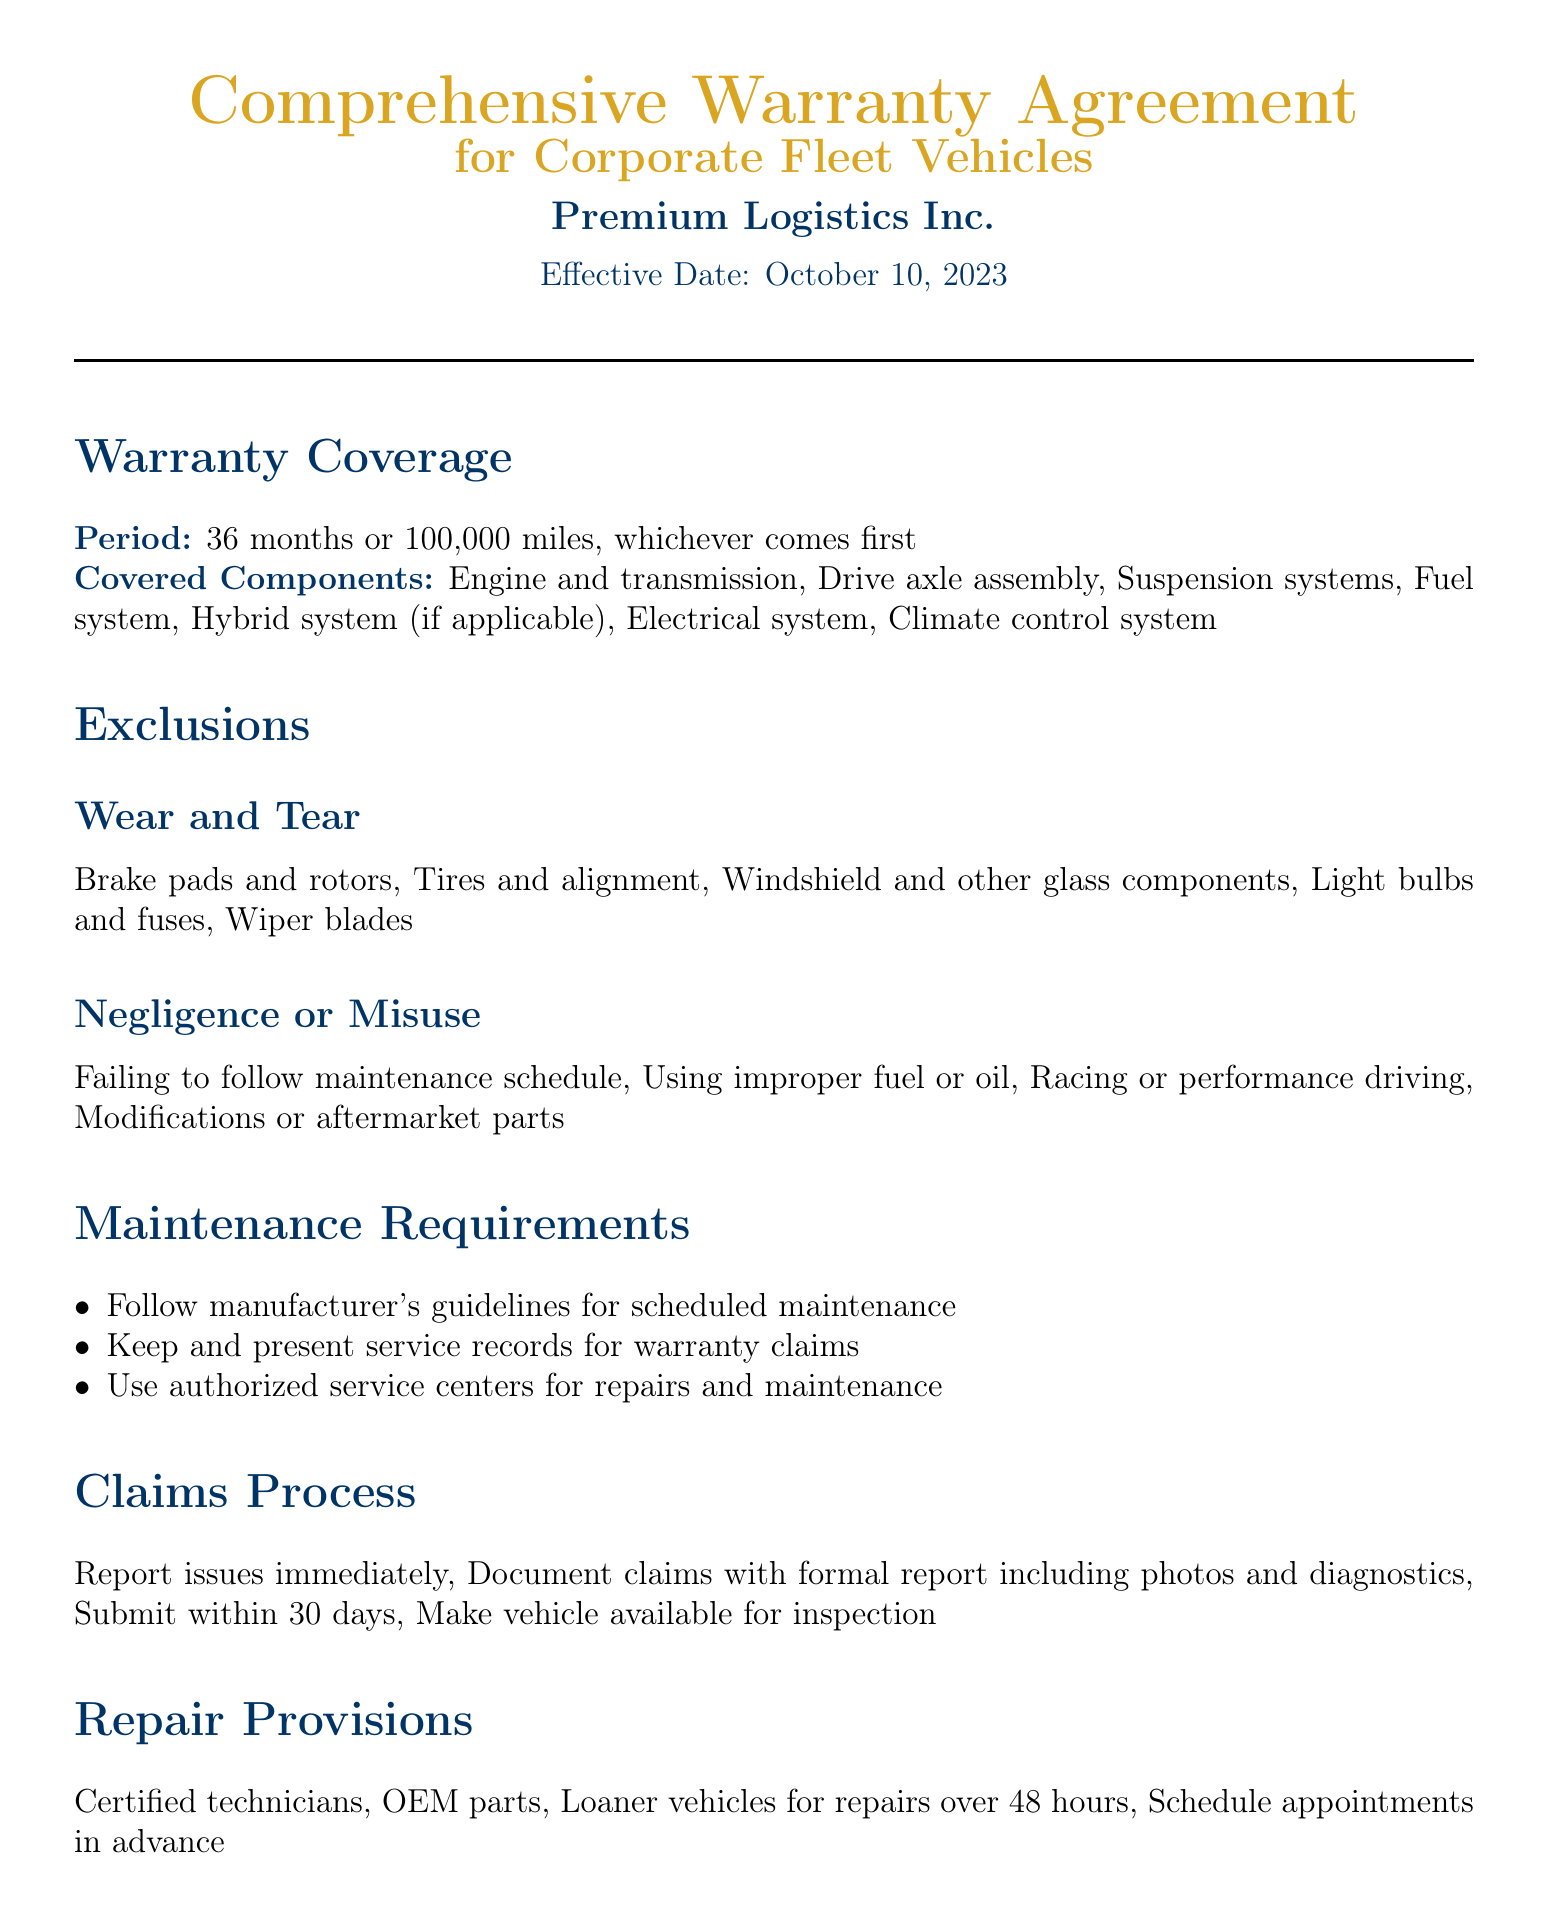What is the warranty period? The warranty period is defined as either 36 months or 100,000 miles, whichever comes first.
Answer: 36 months or 100,000 miles What components are covered? The document lists several components that are covered under the warranty, including the engine and transmission.
Answer: Engine and transmission, Drive axle assembly, Suspension systems, Fuel system, Hybrid system (if applicable), Electrical system, Climate control system What are the wear and tear exclusions? The document specifies certain items that are considered wear and tear and are thus excluded from the warranty coverage.
Answer: Brake pads and rotors, Tires and alignment, Windshield and other glass components, Light bulbs and fuses, Wiper blades How soon must claims be submitted? The document states a time limit for submitting claims after reporting an issue.
Answer: Within 30 days What happens to the warranty if the vehicle is sold? The document outlines one of the conditions under which the warranty would terminate.
Answer: Warranty terminates if vehicle sold/transferred What is required for maintenance? Maintenance requirements are specified in the document, detailing expectations from the vehicle owner.
Answer: Follow manufacturer's guidelines for scheduled maintenance Who performs the repairs? The document specifies what types of technicians will handle repairs under the warranty.
Answer: Certified technicians What address is provided for contact? The document lists the contact address for inquiries related to the warranty.
Answer: 1234 Wealthy Way, Suite 500, Metropolis, NY 10001 What is the limitation of liability for repairs? The warranty document clarifies the extent of liability of Premium Logistics Inc. concerning indirect damages.
Answer: Not liable for indirect, incidental, or consequential damages 